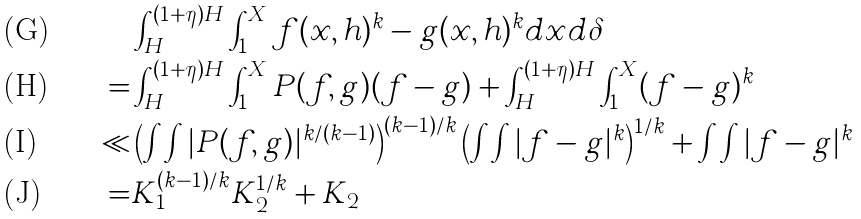<formula> <loc_0><loc_0><loc_500><loc_500>& \int _ { H } ^ { ( 1 + \eta ) H } \int _ { 1 } ^ { X } f ( x , h ) ^ { k } - g ( x , h ) ^ { k } d x d \delta \\ = & \int _ { H } ^ { ( 1 + \eta ) H } \int _ { 1 } ^ { X } P ( f , g ) ( f - g ) + \int _ { H } ^ { ( 1 + \eta ) H } \int _ { 1 } ^ { X } ( f - g ) ^ { k } \\ \ll & \left ( \int \int | P ( f , g ) | ^ { k / ( k - 1 ) } \right ) ^ { ( k - 1 ) / k } \left ( \int \int | f - g | ^ { k } \right ) ^ { 1 / k } + \int \int | f - g | ^ { k } \\ = & K _ { 1 } ^ { ( k - 1 ) / k } K _ { 2 } ^ { 1 / k } + K _ { 2 }</formula> 